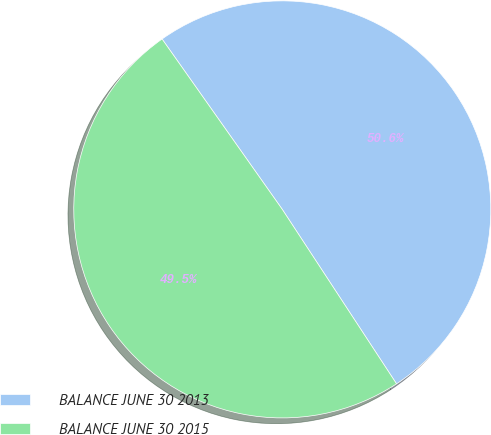Convert chart. <chart><loc_0><loc_0><loc_500><loc_500><pie_chart><fcel>BALANCE JUNE 30 2013<fcel>BALANCE JUNE 30 2015<nl><fcel>50.55%<fcel>49.45%<nl></chart> 